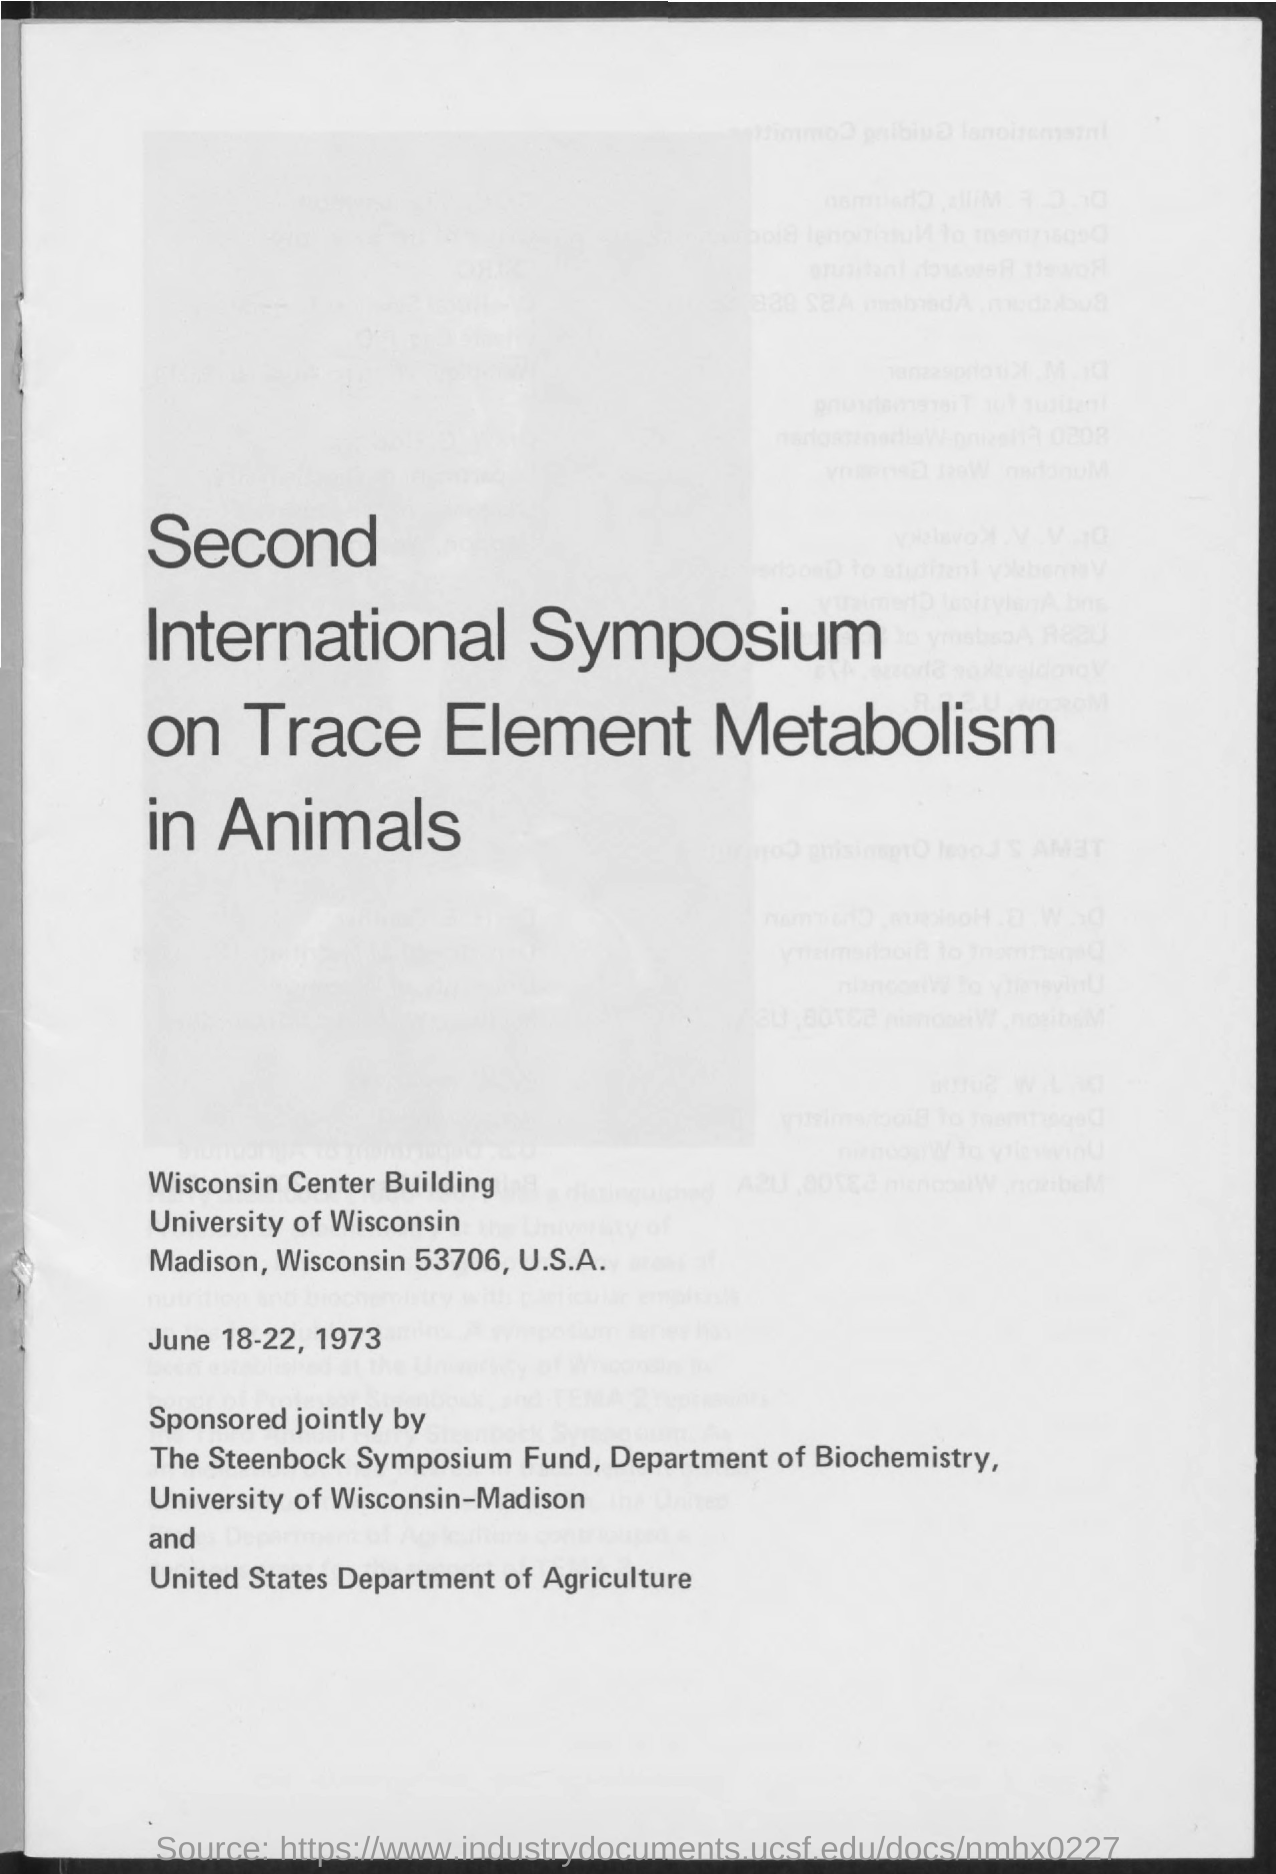Identify some key points in this picture. The Second International Symposium on Trace Element Metabolism in Animals was held from June 18-22, 1973. 